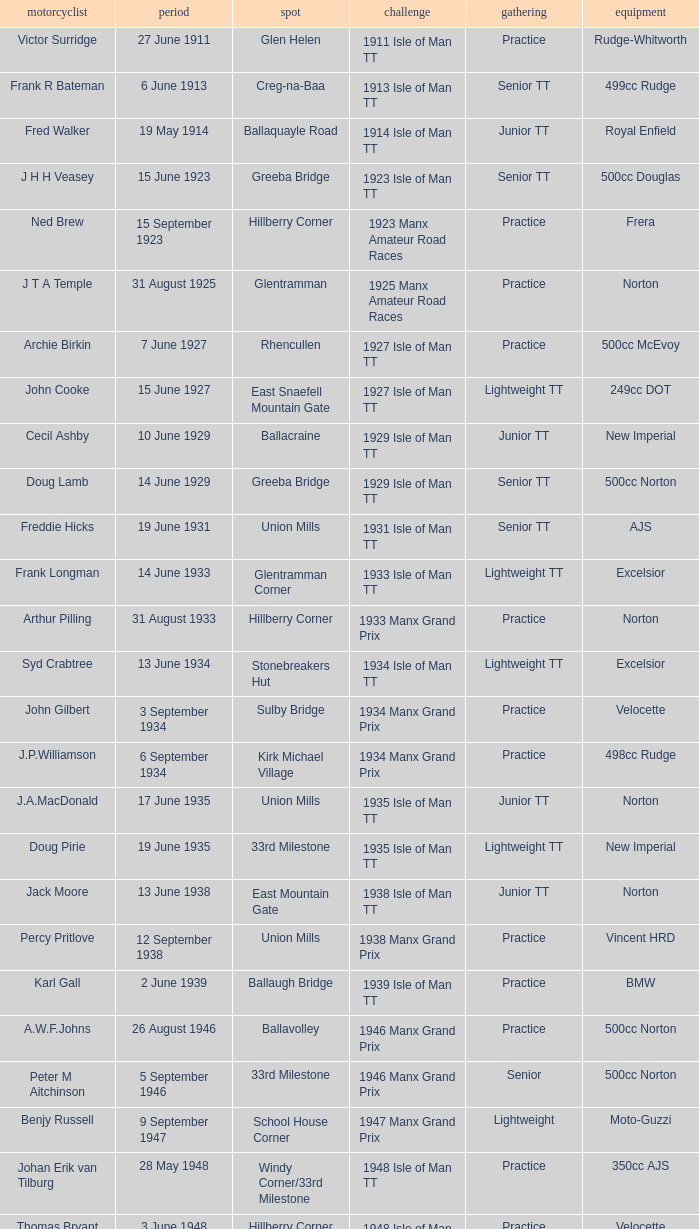In which event was rob vine participating as a rider? Senior TT. 